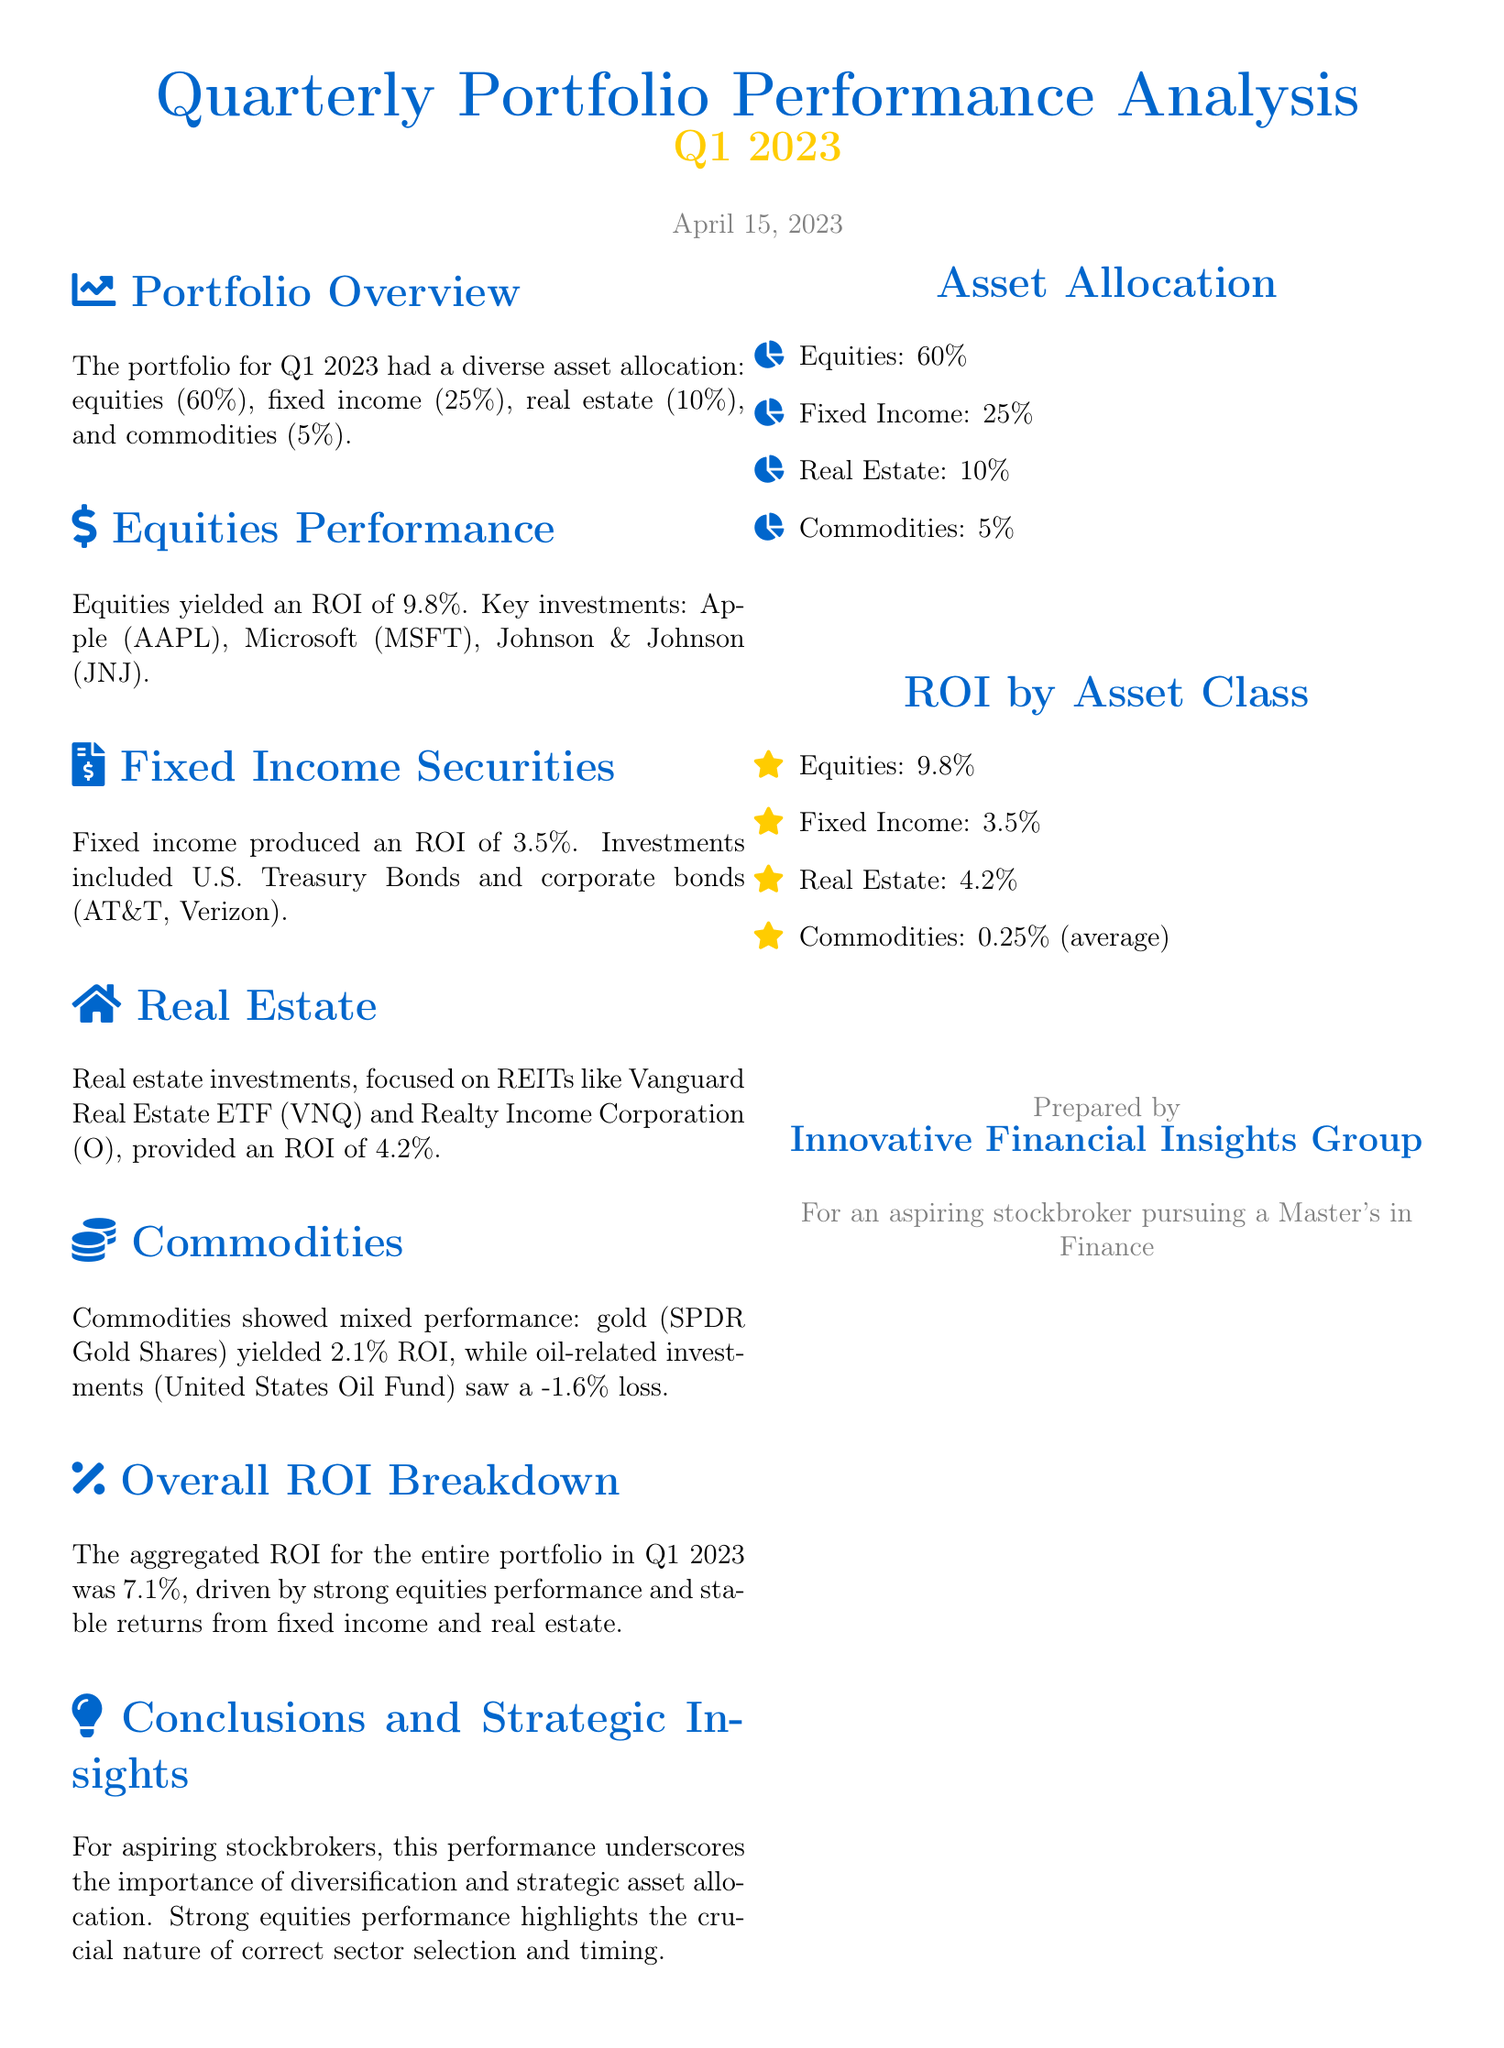What is the date of the analysis? The document states the performance analysis date as April 15, 2023.
Answer: April 15, 2023 What percentage of the portfolio is allocated to fixed income? The document explicitly mentions that fixed income constitutes 25% of the portfolio.
Answer: 25% What was the ROI for equities? The performance section notes that equities yielded an ROI of 9.8%.
Answer: 9.8% Which investment contributed negatively to commodities? The document indicates that the United States Oil Fund saw a -1.6% loss.
Answer: United States Oil Fund What is the overall ROI for the portfolio in Q1 2023? The aggregated ROI for the entire portfolio is summarized as 7.1%.
Answer: 7.1% List the key sectors mentioned in the asset allocation. The document outlines four sectors: equities, fixed income, real estate, and commodities.
Answer: Equities, fixed income, real estate, commodities What does a strong equities performance highlight for stockbrokers? The conclusions highlight the importance of correct sector selection and timing for stockbrokers.
Answer: Correct sector selection and timing Which asset class had the lowest average ROI? The commodities section reveals that commodities had an average ROI of 0.25%.
Answer: 0.25% 